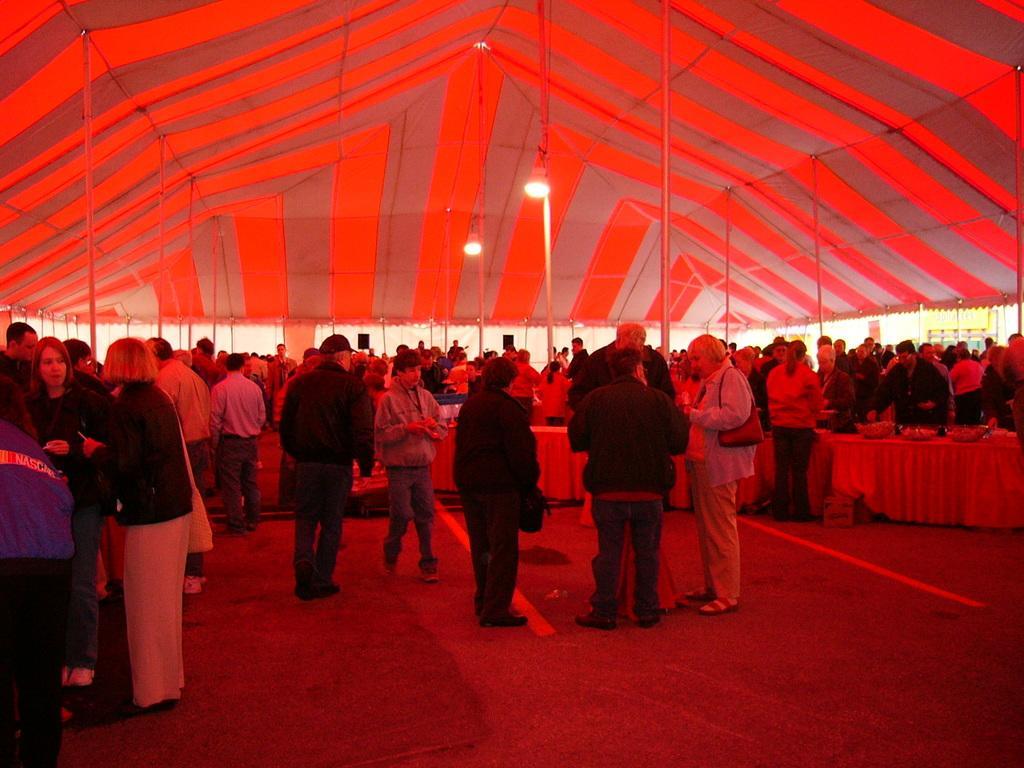Describe this image in one or two sentences. In this picture we can see many people standing under a huge tent. People are standing near the tables also. 